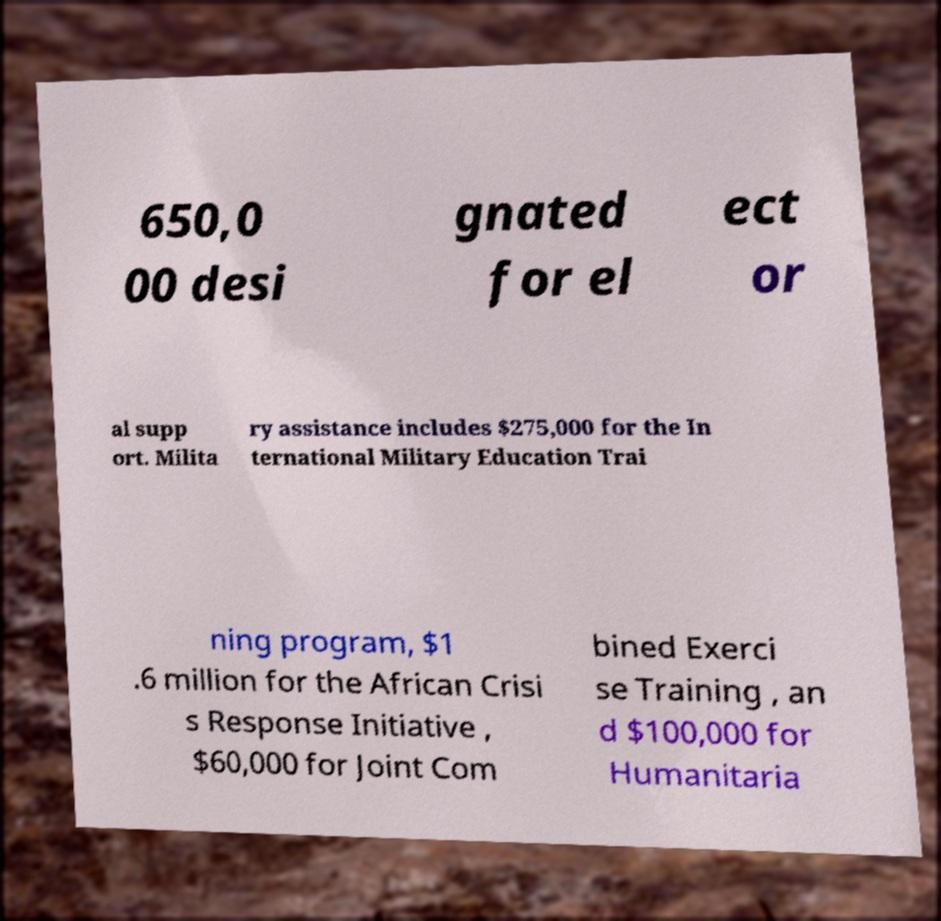I need the written content from this picture converted into text. Can you do that? 650,0 00 desi gnated for el ect or al supp ort. Milita ry assistance includes $275,000 for the In ternational Military Education Trai ning program, $1 .6 million for the African Crisi s Response Initiative , $60,000 for Joint Com bined Exerci se Training , an d $100,000 for Humanitaria 